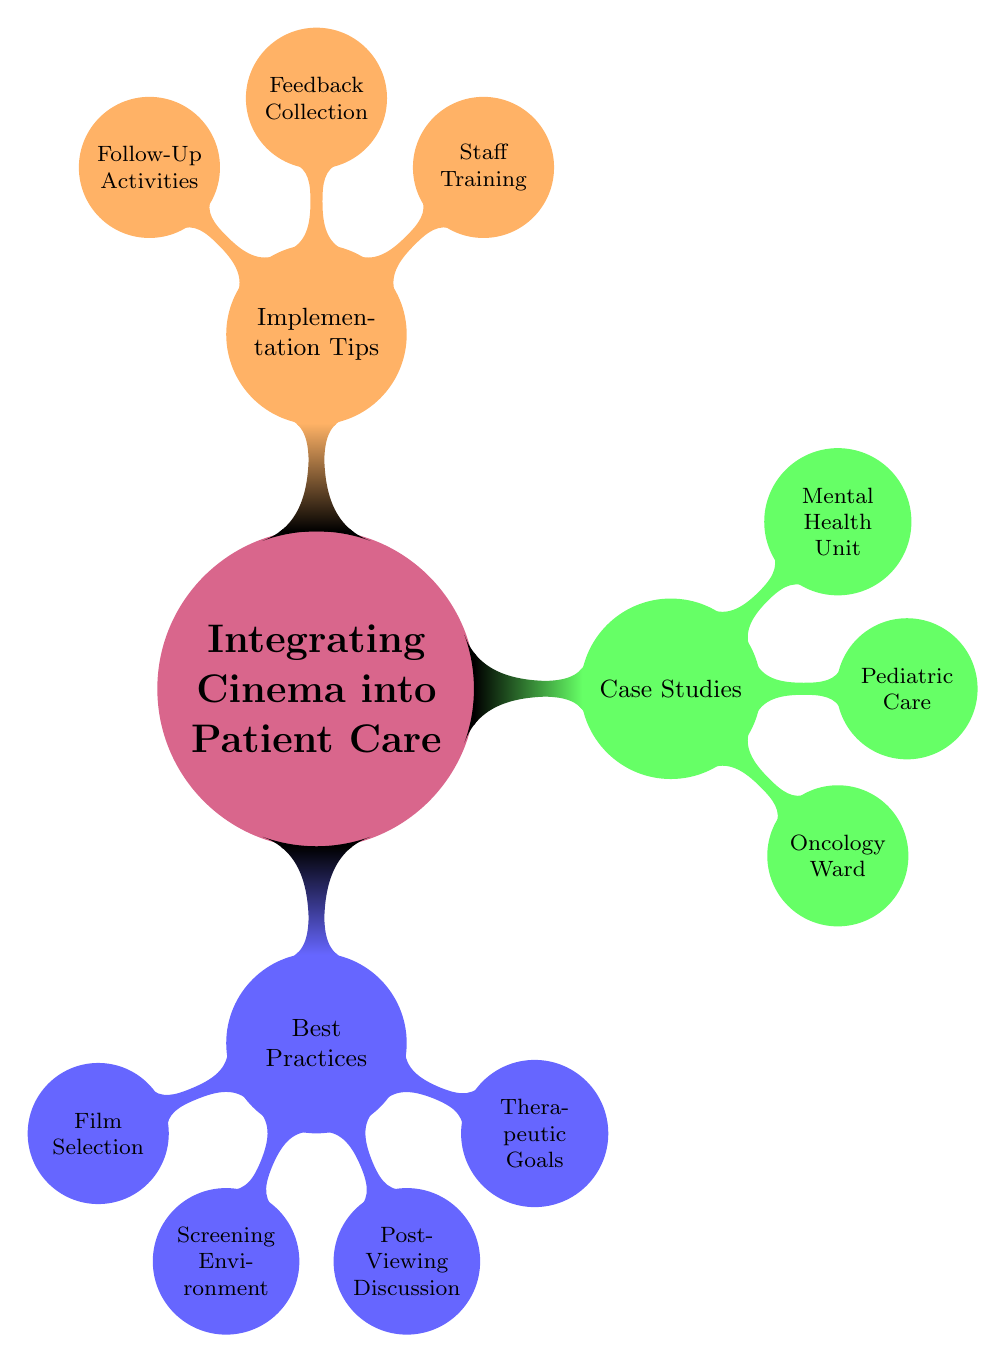What are the three main categories in the mind map? The mind map contains three main categories: Best Practices, Case Studies, and Implementation Tips. These are the primary branches stemming from the central concept.
Answer: Best Practices, Case Studies, Implementation Tips How many specific nodes are under 'Best Practices'? Under 'Best Practices', there are four specific nodes: Film Selection, Screening Environment, Post-Viewing Discussion, and Therapeutic Goals. This includes all the detailed practices listed.
Answer: 4 Which film was used in the Pediatric Care case study? In the Pediatric Care case study, the film used is "Finding Nemo". This is directly noted under the Pediatric Care branch of the Case Studies category.
Answer: Finding Nemo What is one therapeutic goal listed in the Best Practices? One of the therapeutic goals listed in the Best Practices is "Emotional Expression", which is a key component of therapeutic cinema use.
Answer: Emotional Expression Which unit had "Improved Emotional Literacy" as an outcome and what film was used? The Mental Health Unit had "Improved Emotional Literacy" as an outcome, and the film used was "Inside Out". This combines a specific unit with its outcome and associated film.
Answer: Inside Out How many case studies are presented in the mind map? The mind map presents three case studies: Oncology Ward, Pediatric Care, and Mental Health Unit. These are the unique applications of cinema in patient care that are explored.
Answer: 3 What is one implementation tip related to staff training? One implementation tip related to staff training is "Understanding Film Therapy". This is essential for staff to effectively integrate cinema into patient care.
Answer: Understanding Film Therapy What is a post-viewing discussion activity suggested in the mind map? A suggested post-viewing discussion activity is "Facilitated Group Discourse", which encourages sharing insights and experiences after watching a film.
Answer: Facilitated Group Discourse What is the outcome of the film used in the Oncology Ward? The outcome of the film used in the Oncology Ward, "The Bucket List", is "Increased Patient Morale". This demonstrates the positive effects of cinematic storytelling on patients.
Answer: Increased Patient Morale 